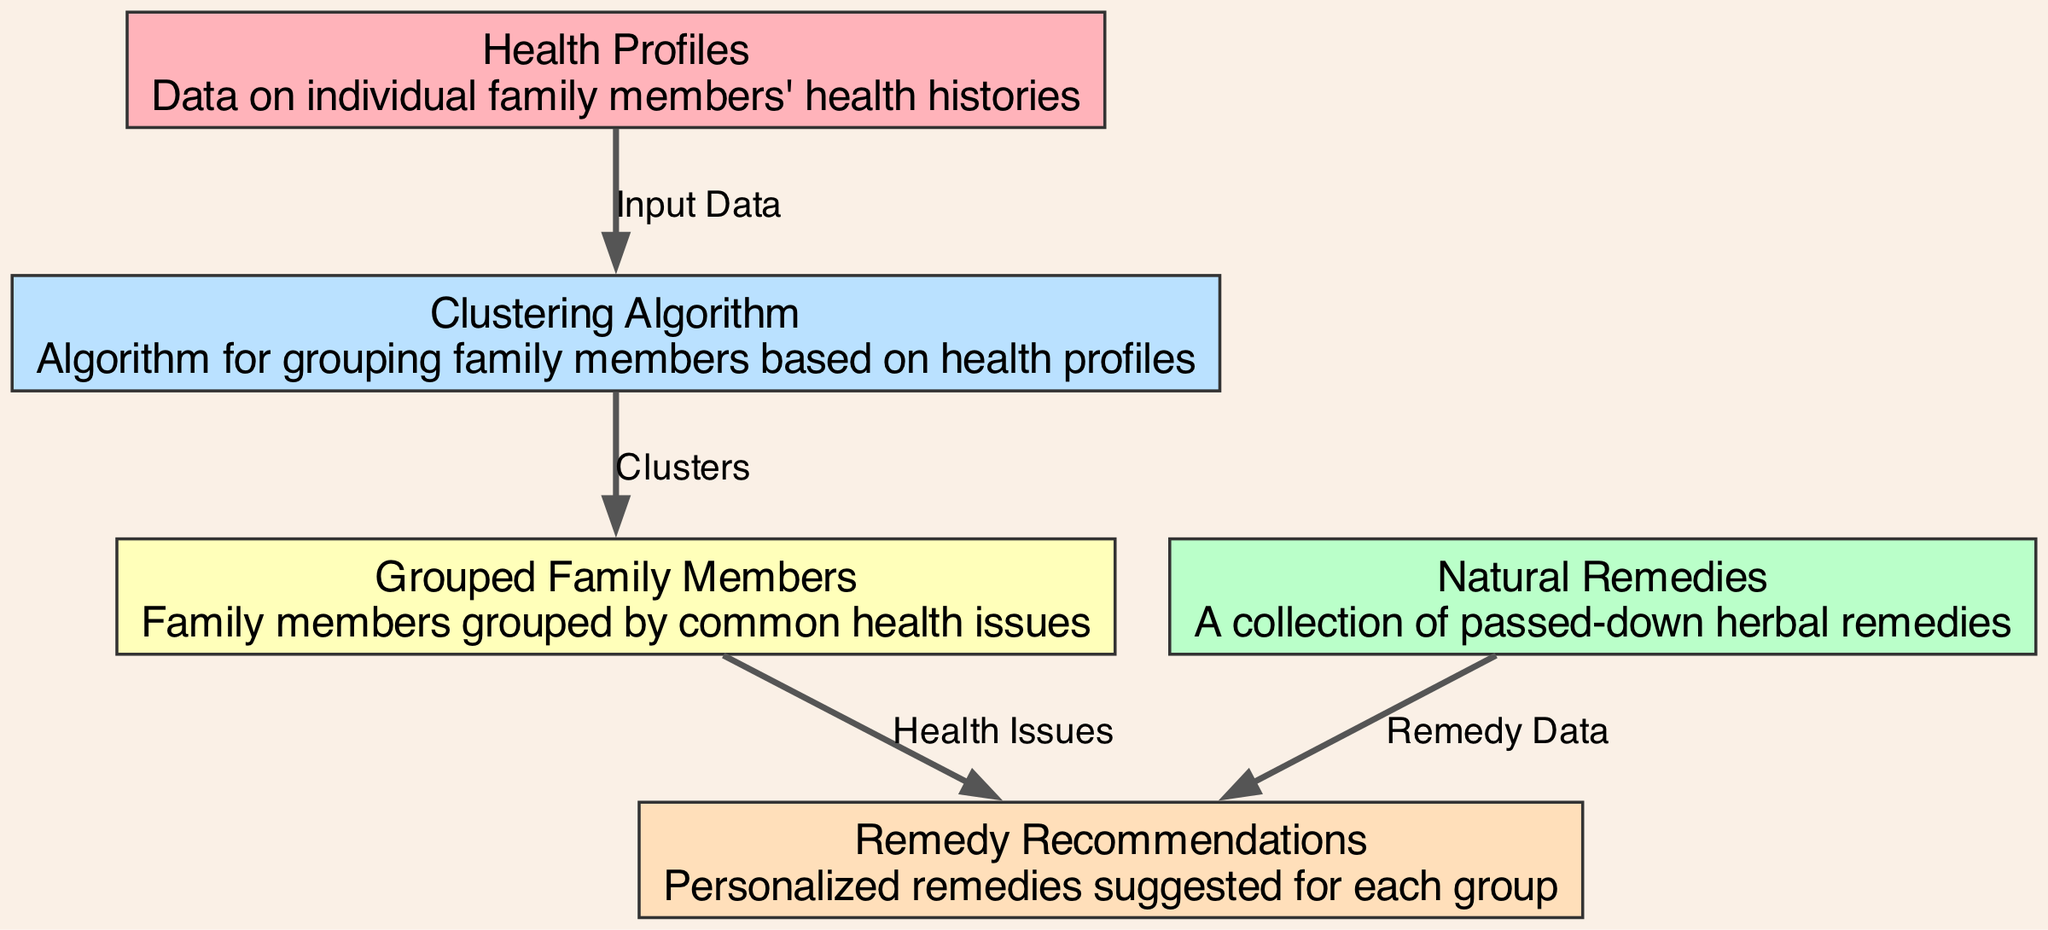What is the first node in the diagram? The first node listed in the "nodes" section is "Health Profiles," which is the starting point of the data flow in the diagram.
Answer: Health Profiles How many total nodes are in the diagram? By counting the items listed in the "nodes" section, there are five nodes total in the diagram.
Answer: 5 What type of algorithm is used in the diagram? The node "clustering_algorithm" indicates that a clustering algorithm is utilized for grouping family members based on their health profiles.
Answer: Clustering Algorithm Which node receives the output from the clustering algorithm? The node labeled "Grouped Family Members" directly receives output from the "clustering_algorithm," as indicated by an edge connecting the two.
Answer: Grouped Family Members What connects the health profiles to the clustering algorithm? The edge connecting "health_profiles" to "clustering_algorithm" indicates that "Input Data" is the relationship, showing that health profiles serve as input for the algorithm.
Answer: Input Data Which node is associated with remedy data? The node "natural_remedies" is connected to "remedy_recommendations," indicating that this node provides the remedy data needed for recommendations.
Answer: Natural Remedies How do remedy recommendations relate to grouped family members? There is an edge between "grouped_family_members" and "remedy_recommendations" labeled "Health Issues," showing that the recommendations are based on the health issues of the grouped family members.
Answer: Health Issues What is the purpose of the clustering algorithm in the context of the diagram? The clustering algorithm's purpose is to group family members based on their health profiles, which is indicated by the flow from health profiles to the grouped family members.
Answer: Grouping Which node provides the final personalized remedies? The "remedy_recommendations" node provides the final personalized herbal remedies based on the grouped family members' health issues.
Answer: Remedy Recommendations 